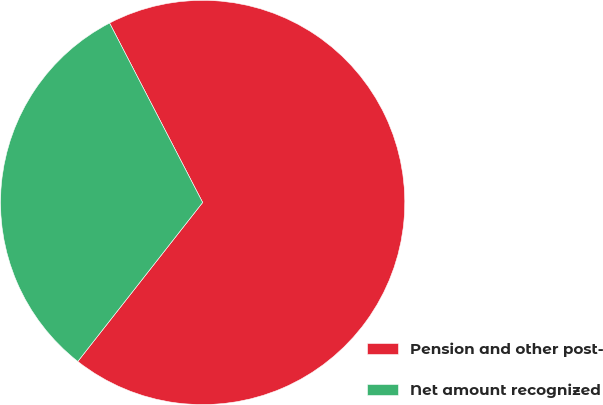Convert chart to OTSL. <chart><loc_0><loc_0><loc_500><loc_500><pie_chart><fcel>Pension and other post-<fcel>Net amount recognized<nl><fcel>68.21%<fcel>31.79%<nl></chart> 